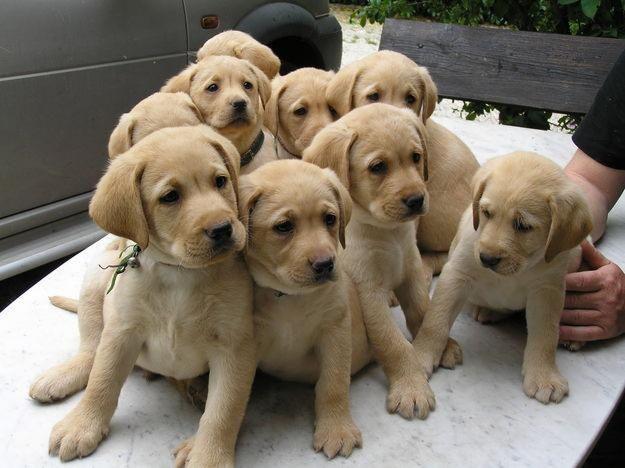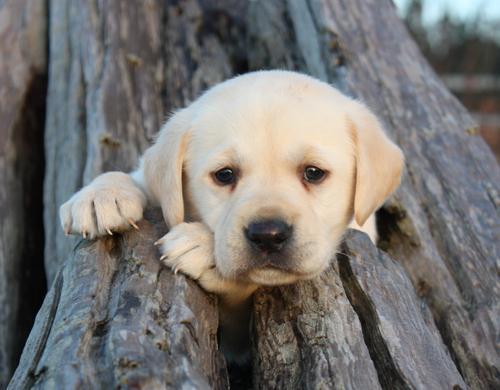The first image is the image on the left, the second image is the image on the right. Examine the images to the left and right. Is the description "there are two puppies in the image pair" accurate? Answer yes or no. No. The first image is the image on the left, the second image is the image on the right. Analyze the images presented: Is the assertion "One dog has something around its neck." valid? Answer yes or no. No. 